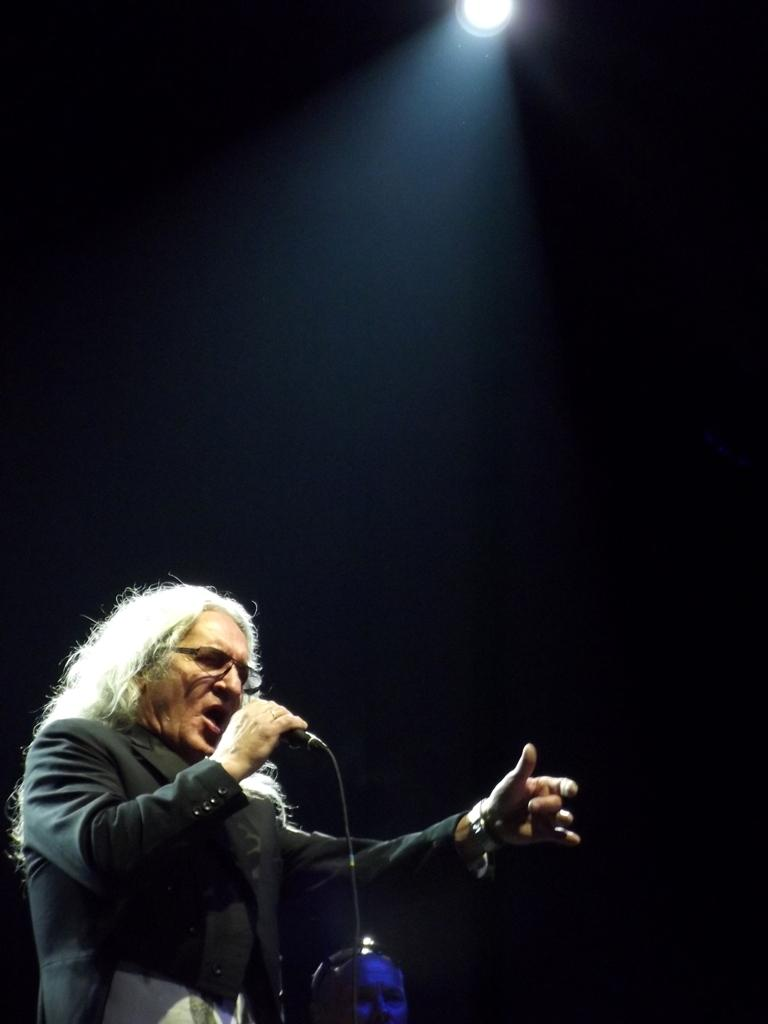What is the main subject of the image? There is a person in the image. What is the person wearing? The person is wearing a black dress. What is the person holding in the image? The person is holding a microphone. What can be seen in the background of the image? There is a light in the background of the image. How does the person's sweater compare to the microphone in the image? There is no sweater mentioned in the image; the person is wearing a black dress. 